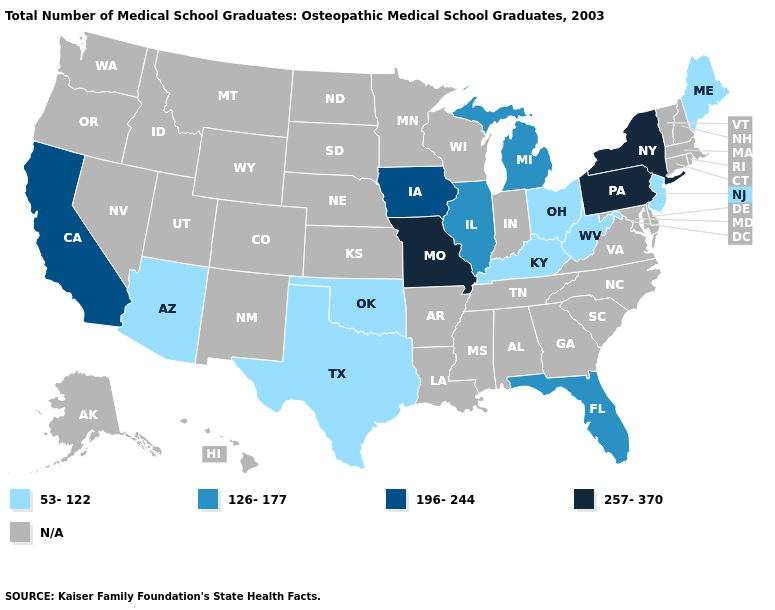Among the states that border West Virginia , does Kentucky have the lowest value?
Quick response, please. Yes. Name the states that have a value in the range 257-370?
Be succinct. Missouri, New York, Pennsylvania. Name the states that have a value in the range 126-177?
Quick response, please. Florida, Illinois, Michigan. What is the value of Connecticut?
Short answer required. N/A. Which states have the lowest value in the USA?
Quick response, please. Arizona, Kentucky, Maine, New Jersey, Ohio, Oklahoma, Texas, West Virginia. Name the states that have a value in the range 53-122?
Answer briefly. Arizona, Kentucky, Maine, New Jersey, Ohio, Oklahoma, Texas, West Virginia. Does Arizona have the lowest value in the USA?
Give a very brief answer. Yes. Does Ohio have the lowest value in the MidWest?
Write a very short answer. Yes. What is the lowest value in the West?
Short answer required. 53-122. Among the states that border New York , does New Jersey have the highest value?
Answer briefly. No. Among the states that border Virginia , which have the highest value?
Keep it brief. Kentucky, West Virginia. Does California have the lowest value in the West?
Write a very short answer. No. Name the states that have a value in the range 126-177?
Answer briefly. Florida, Illinois, Michigan. Does the map have missing data?
Be succinct. Yes. 